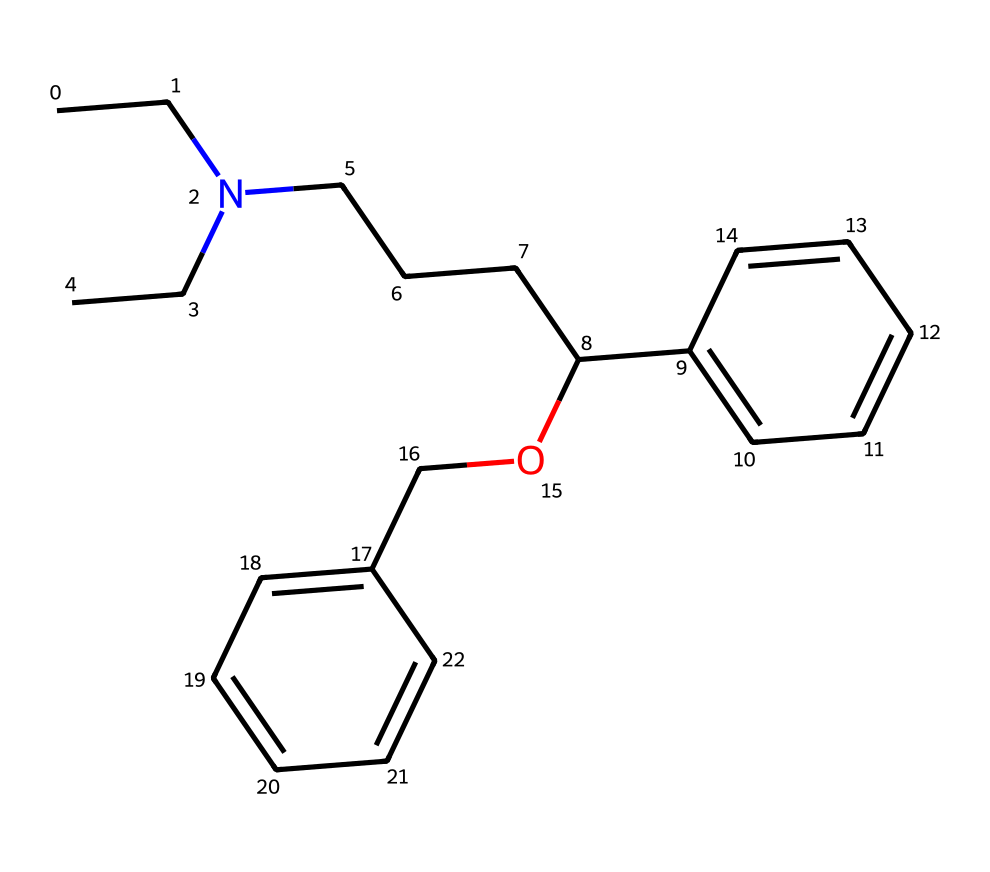What is the primary functional group in this chemical? The primary functional group is identified by looking for the -OH (alcohol) group in the structure. In this SMILES representation, there is an -OH group connected to a carbon chain, indicating that this compound has an alcohol functional group.
Answer: alcohol How many carbon atoms are present in this structure? To determine the number of carbon atoms, we count each carbon in the SMILES representation, including those in rings and branches. There are a total of 19 carbon atoms in this chemical.
Answer: 19 What type of drug is represented by this chemical structure? This chemical structure has characteristics and functional groups common to serotonin reuptake inhibitors. The presence of a long carbon chain combined with aromatic rings suggests it is used to modify neurotransmitter levels.
Answer: serotonin reuptake inhibitor Is there a ring structure present in this chemical? By examining the SMILES, we can look for the numbers that indicate ring closures, such as ‘1’ and ‘2’. The chemical shows two distinct ring structures. This is confirmed as there are two numbering instances indicating closed loops.
Answer: yes What is the total number of nitrogen atoms in the compound? In the SMILES representation, ‘N’ stands for nitrogen, and we can count the occurrences. The structure contains one nitrogen atom.
Answer: 1 Which aromatic compound is present in this chemical? Aromatic compounds can be identified by the presence of benzene-like structures in the SMILES, which show alternating double bonds or are noted with lower case letters. In this case, there are two benzene rings present, indicating the structure has significant aromatic properties.
Answer: benzene What is the significance of the -O- linkage in this drug? The -O- linkage in the structure indicates an ether or alcohol that could influence the drug’s solubility and interaction with its target receptors in the brain, playing a critical role in its effectiveness as a drug in treating depression and anxiety.
Answer: solubility 